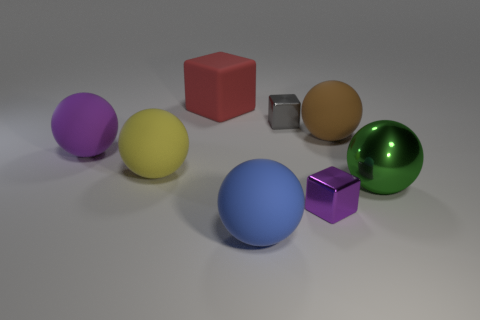Do the big red object and the metallic thing that is left of the purple metallic object have the same shape?
Provide a succinct answer. Yes. What number of purple things are behind the purple rubber object?
Ensure brevity in your answer.  0. Are there any yellow shiny cubes of the same size as the red block?
Your response must be concise. No. Do the purple object to the right of the rubber cube and the tiny gray metallic thing have the same shape?
Give a very brief answer. Yes. The large metallic thing is what color?
Make the answer very short. Green. Are any large red things visible?
Provide a succinct answer. Yes. There is a blue thing that is made of the same material as the big brown object; what size is it?
Give a very brief answer. Large. There is a large matte object that is in front of the tiny shiny thing that is in front of the tiny thing to the left of the purple block; what is its shape?
Give a very brief answer. Sphere. Are there the same number of small gray cubes on the left side of the big red rubber thing and small blue blocks?
Give a very brief answer. Yes. Is the shape of the big purple rubber thing the same as the tiny purple metallic thing?
Offer a very short reply. No. 